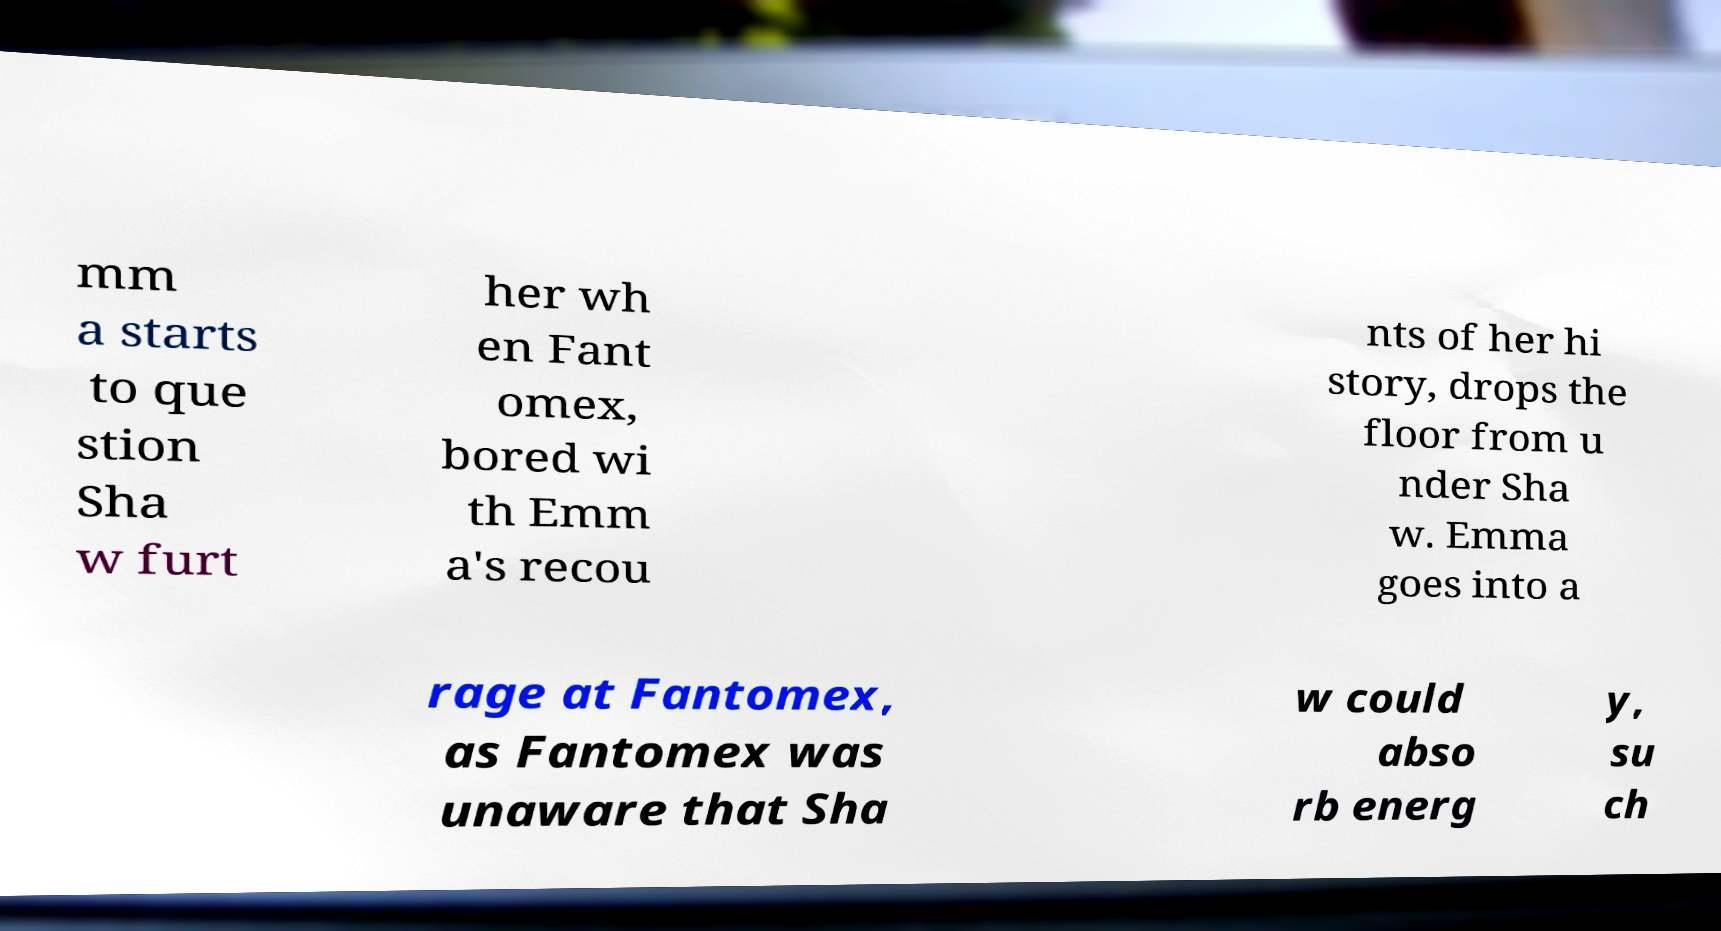Could you extract and type out the text from this image? mm a starts to que stion Sha w furt her wh en Fant omex, bored wi th Emm a's recou nts of her hi story, drops the floor from u nder Sha w. Emma goes into a rage at Fantomex, as Fantomex was unaware that Sha w could abso rb energ y, su ch 